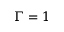<formula> <loc_0><loc_0><loc_500><loc_500>\Gamma = 1</formula> 